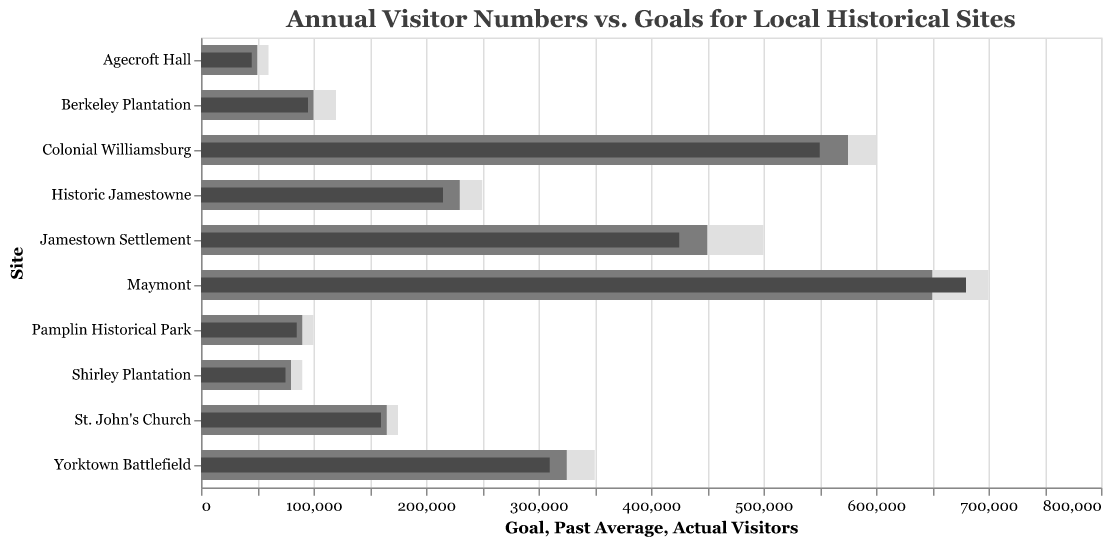What is the title of the chart? The title of the chart is at the top of the figure in large, bold text. It indicates the overall subject of the visualization, which is the comparison of actual visitor numbers against goals.
Answer: Annual Visitor Numbers vs. Goals for Local Historical Sites Which historical site had the highest actual visitors? To find the historical site with the highest actual visitors, look for the longest dark gray bar, which represents the actual visitors.
Answer: Maymont Which historical site had the smallest goal? To find the historical site with the smallest goal, look for the shortest light gray bar, which represents the goal value.
Answer: Agecroft Hall What is the difference between the goals and actual visitors for Colonial Williamsburg? Subtract the actual visitor number from the goal number for Colonial Williamsburg: 600,000 (Goal) - 550,000 (Actual Visitors).
Answer: 50,000 Compare the actual visitors for Jamestown Settlement and Historic Jamestowne. Which site had more visitors and by how much? Subtract the actual visitor number of Historic Jamestowne from that of Jamestown Settlement: 425,000 (Jamestown Settlement) - 215,000 (Historic Jamestowne).
Answer: Jamestown Settlement, 210,000 more visitors How does the past average of visitors at Berkeley Plantation compare to the actual visitors? Compare the actual visitors and past average visitors for Berkeley Plantation by looking at the length of the medium gray bar (past average) and the dark gray bar (actual visitors): 100,000 (Past Average) - 95,000 (Actual Visitors).
Answer: 5,000 more in past average Which site had the highest goal and did it meet that goal? Identify the longest light gray bar to find the highest goal, which is for Maymont. Compare it with the dark gray bar (actual visitors): 700,000 (Goal) vs. 680,000 (Actual Visitors).
Answer: Maymont, No What's the average of the past visitor averages for all sites? Sum the past averages of visitors for all sites and divide by the number of sites: (450,000 + 575,000 + 325,000 + 230,000 + 100,000 + 80,000 + 165,000 + 650,000 + 50,000 + 90,000) / 10 = 2715,000 / 10.
Answer: 271,500 Which sites surpassed their past average visitor numbers? Compare the actual visitor numbers with past averages for all sites. The sites where the actual visitors are greater than past averages are the ones that surpassed their past averages: Maymont (680,000 vs. 650,000).
Answer: Maymont Which site had the largest shortfall between actual visitors and its goal? Subtract actual visitors from the goal for each site and find the site with the largest positive difference: Jamestown Settlement (75,000), Colonial Williamsburg (50,000), Yorktown Battlefield (40,000), Historic Jamestowne (35,000), Berkeley Plantation (25,000), Shirley Plantation (15,000), St. John's Church (15,000), Maymont (20,000), Agecroft Hall (15,000), Pamplin Historical Park (15,000). Largest shortfall is Jamestown Settlement.
Answer: Jamestown Settlement, 75,000 